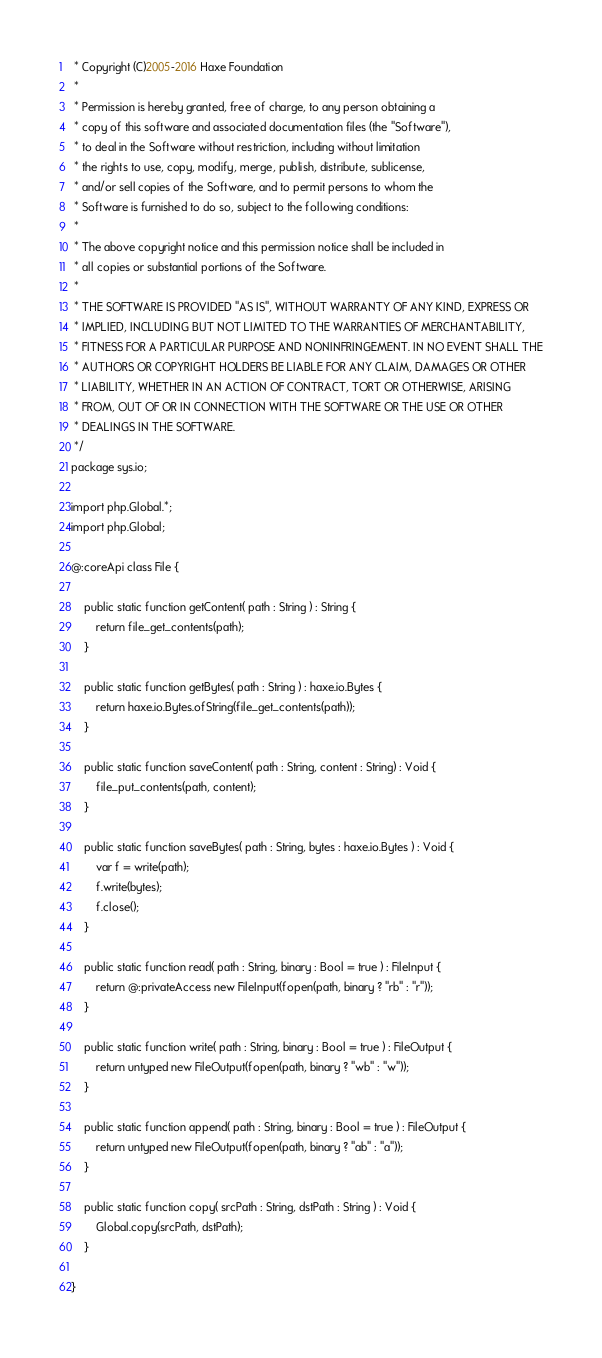<code> <loc_0><loc_0><loc_500><loc_500><_Haxe_> * Copyright (C)2005-2016 Haxe Foundation
 *
 * Permission is hereby granted, free of charge, to any person obtaining a
 * copy of this software and associated documentation files (the "Software"),
 * to deal in the Software without restriction, including without limitation
 * the rights to use, copy, modify, merge, publish, distribute, sublicense,
 * and/or sell copies of the Software, and to permit persons to whom the
 * Software is furnished to do so, subject to the following conditions:
 *
 * The above copyright notice and this permission notice shall be included in
 * all copies or substantial portions of the Software.
 *
 * THE SOFTWARE IS PROVIDED "AS IS", WITHOUT WARRANTY OF ANY KIND, EXPRESS OR
 * IMPLIED, INCLUDING BUT NOT LIMITED TO THE WARRANTIES OF MERCHANTABILITY,
 * FITNESS FOR A PARTICULAR PURPOSE AND NONINFRINGEMENT. IN NO EVENT SHALL THE
 * AUTHORS OR COPYRIGHT HOLDERS BE LIABLE FOR ANY CLAIM, DAMAGES OR OTHER
 * LIABILITY, WHETHER IN AN ACTION OF CONTRACT, TORT OR OTHERWISE, ARISING
 * FROM, OUT OF OR IN CONNECTION WITH THE SOFTWARE OR THE USE OR OTHER
 * DEALINGS IN THE SOFTWARE.
 */
package sys.io;

import php.Global.*;
import php.Global;

@:coreApi class File {

	public static function getContent( path : String ) : String {
		return file_get_contents(path);
	}

	public static function getBytes( path : String ) : haxe.io.Bytes {
		return haxe.io.Bytes.ofString(file_get_contents(path));
	}

	public static function saveContent( path : String, content : String) : Void {
		file_put_contents(path, content);
	}

	public static function saveBytes( path : String, bytes : haxe.io.Bytes ) : Void {
		var f = write(path);
		f.write(bytes);
		f.close();
	}

	public static function read( path : String, binary : Bool = true ) : FileInput {
		return @:privateAccess new FileInput(fopen(path, binary ? "rb" : "r"));
	}

	public static function write( path : String, binary : Bool = true ) : FileOutput {
		return untyped new FileOutput(fopen(path, binary ? "wb" : "w"));
	}

	public static function append( path : String, binary : Bool = true ) : FileOutput {
		return untyped new FileOutput(fopen(path, binary ? "ab" : "a"));
	}

	public static function copy( srcPath : String, dstPath : String ) : Void {
		Global.copy(srcPath, dstPath);
	}

}
</code> 